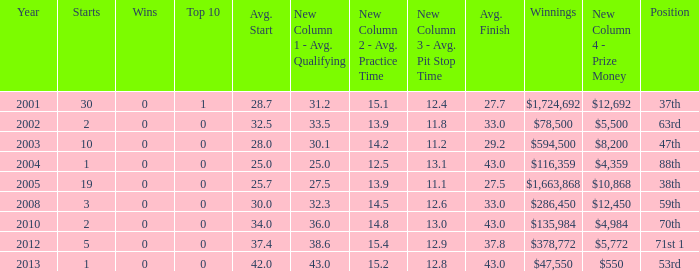How many wins for average start less than 25? 0.0. 